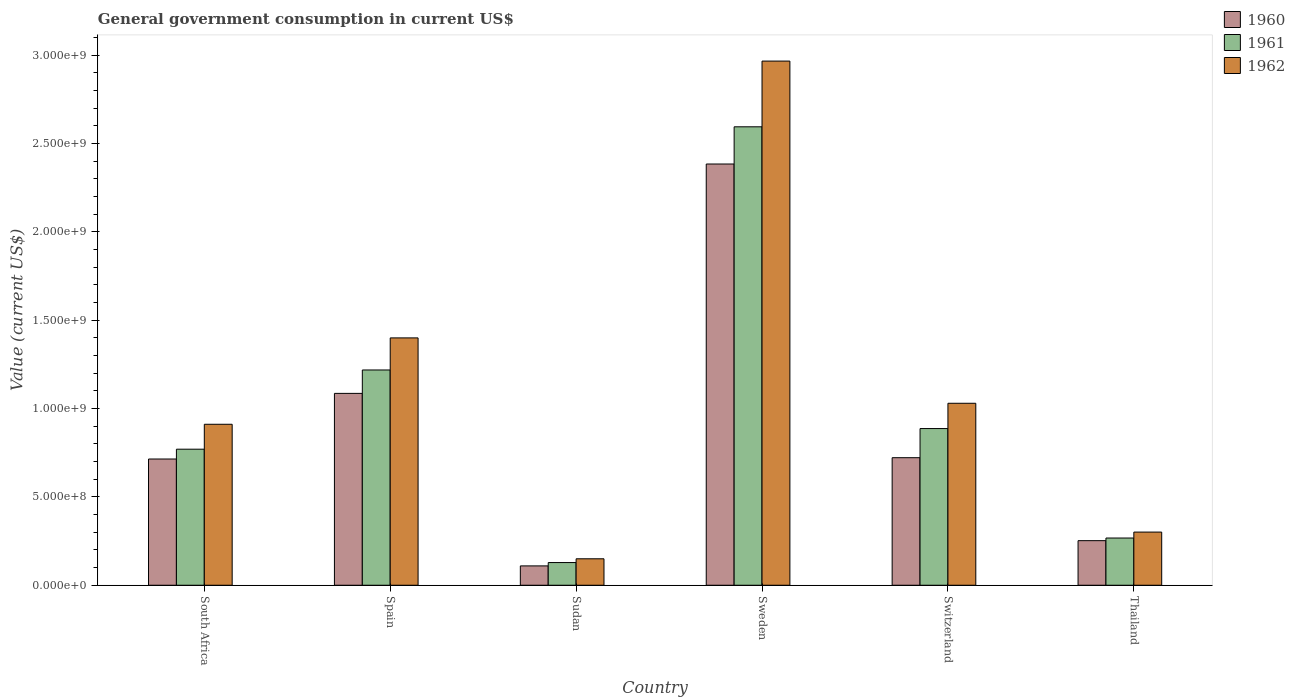How many groups of bars are there?
Your answer should be very brief. 6. Are the number of bars per tick equal to the number of legend labels?
Keep it short and to the point. Yes. Are the number of bars on each tick of the X-axis equal?
Offer a very short reply. Yes. How many bars are there on the 3rd tick from the left?
Ensure brevity in your answer.  3. How many bars are there on the 5th tick from the right?
Keep it short and to the point. 3. What is the label of the 4th group of bars from the left?
Ensure brevity in your answer.  Sweden. What is the government conusmption in 1962 in Sudan?
Your response must be concise. 1.50e+08. Across all countries, what is the maximum government conusmption in 1961?
Make the answer very short. 2.59e+09. Across all countries, what is the minimum government conusmption in 1962?
Your answer should be compact. 1.50e+08. In which country was the government conusmption in 1960 maximum?
Your answer should be very brief. Sweden. In which country was the government conusmption in 1960 minimum?
Your response must be concise. Sudan. What is the total government conusmption in 1962 in the graph?
Your response must be concise. 6.76e+09. What is the difference between the government conusmption in 1960 in Sudan and that in Sweden?
Ensure brevity in your answer.  -2.27e+09. What is the difference between the government conusmption in 1961 in Thailand and the government conusmption in 1960 in Switzerland?
Your response must be concise. -4.54e+08. What is the average government conusmption in 1961 per country?
Provide a short and direct response. 9.77e+08. What is the difference between the government conusmption of/in 1961 and government conusmption of/in 1960 in Thailand?
Ensure brevity in your answer.  1.50e+07. In how many countries, is the government conusmption in 1960 greater than 2700000000 US$?
Provide a succinct answer. 0. What is the ratio of the government conusmption in 1962 in South Africa to that in Spain?
Provide a succinct answer. 0.65. Is the difference between the government conusmption in 1961 in Spain and Sudan greater than the difference between the government conusmption in 1960 in Spain and Sudan?
Give a very brief answer. Yes. What is the difference between the highest and the second highest government conusmption in 1962?
Provide a short and direct response. 1.57e+09. What is the difference between the highest and the lowest government conusmption in 1960?
Provide a short and direct response. 2.27e+09. What does the 1st bar from the left in Thailand represents?
Give a very brief answer. 1960. What does the 1st bar from the right in Spain represents?
Your answer should be compact. 1962. How many bars are there?
Offer a terse response. 18. Are all the bars in the graph horizontal?
Give a very brief answer. No. What is the difference between two consecutive major ticks on the Y-axis?
Provide a short and direct response. 5.00e+08. Are the values on the major ticks of Y-axis written in scientific E-notation?
Provide a short and direct response. Yes. Does the graph contain grids?
Provide a succinct answer. No. How many legend labels are there?
Give a very brief answer. 3. How are the legend labels stacked?
Your answer should be very brief. Vertical. What is the title of the graph?
Offer a very short reply. General government consumption in current US$. Does "1990" appear as one of the legend labels in the graph?
Offer a very short reply. No. What is the label or title of the Y-axis?
Your answer should be very brief. Value (current US$). What is the Value (current US$) in 1960 in South Africa?
Your answer should be compact. 7.14e+08. What is the Value (current US$) in 1961 in South Africa?
Keep it short and to the point. 7.70e+08. What is the Value (current US$) in 1962 in South Africa?
Give a very brief answer. 9.11e+08. What is the Value (current US$) of 1960 in Spain?
Your answer should be very brief. 1.09e+09. What is the Value (current US$) in 1961 in Spain?
Offer a very short reply. 1.22e+09. What is the Value (current US$) of 1962 in Spain?
Keep it short and to the point. 1.40e+09. What is the Value (current US$) in 1960 in Sudan?
Your answer should be compact. 1.09e+08. What is the Value (current US$) of 1961 in Sudan?
Your answer should be very brief. 1.28e+08. What is the Value (current US$) of 1962 in Sudan?
Give a very brief answer. 1.50e+08. What is the Value (current US$) in 1960 in Sweden?
Make the answer very short. 2.38e+09. What is the Value (current US$) in 1961 in Sweden?
Offer a very short reply. 2.59e+09. What is the Value (current US$) in 1962 in Sweden?
Your answer should be very brief. 2.97e+09. What is the Value (current US$) of 1960 in Switzerland?
Make the answer very short. 7.22e+08. What is the Value (current US$) of 1961 in Switzerland?
Offer a terse response. 8.86e+08. What is the Value (current US$) in 1962 in Switzerland?
Ensure brevity in your answer.  1.03e+09. What is the Value (current US$) in 1960 in Thailand?
Ensure brevity in your answer.  2.52e+08. What is the Value (current US$) in 1961 in Thailand?
Your response must be concise. 2.67e+08. What is the Value (current US$) in 1962 in Thailand?
Ensure brevity in your answer.  3.01e+08. Across all countries, what is the maximum Value (current US$) of 1960?
Your answer should be compact. 2.38e+09. Across all countries, what is the maximum Value (current US$) in 1961?
Your answer should be compact. 2.59e+09. Across all countries, what is the maximum Value (current US$) in 1962?
Provide a succinct answer. 2.97e+09. Across all countries, what is the minimum Value (current US$) of 1960?
Your answer should be compact. 1.09e+08. Across all countries, what is the minimum Value (current US$) of 1961?
Give a very brief answer. 1.28e+08. Across all countries, what is the minimum Value (current US$) in 1962?
Offer a very short reply. 1.50e+08. What is the total Value (current US$) in 1960 in the graph?
Provide a short and direct response. 5.27e+09. What is the total Value (current US$) of 1961 in the graph?
Provide a succinct answer. 5.86e+09. What is the total Value (current US$) of 1962 in the graph?
Your answer should be compact. 6.76e+09. What is the difference between the Value (current US$) of 1960 in South Africa and that in Spain?
Make the answer very short. -3.71e+08. What is the difference between the Value (current US$) in 1961 in South Africa and that in Spain?
Offer a very short reply. -4.48e+08. What is the difference between the Value (current US$) in 1962 in South Africa and that in Spain?
Provide a succinct answer. -4.89e+08. What is the difference between the Value (current US$) of 1960 in South Africa and that in Sudan?
Offer a terse response. 6.05e+08. What is the difference between the Value (current US$) in 1961 in South Africa and that in Sudan?
Make the answer very short. 6.41e+08. What is the difference between the Value (current US$) in 1962 in South Africa and that in Sudan?
Ensure brevity in your answer.  7.61e+08. What is the difference between the Value (current US$) in 1960 in South Africa and that in Sweden?
Give a very brief answer. -1.67e+09. What is the difference between the Value (current US$) of 1961 in South Africa and that in Sweden?
Offer a very short reply. -1.82e+09. What is the difference between the Value (current US$) in 1962 in South Africa and that in Sweden?
Give a very brief answer. -2.05e+09. What is the difference between the Value (current US$) in 1960 in South Africa and that in Switzerland?
Offer a terse response. -7.44e+06. What is the difference between the Value (current US$) in 1961 in South Africa and that in Switzerland?
Your answer should be compact. -1.17e+08. What is the difference between the Value (current US$) of 1962 in South Africa and that in Switzerland?
Ensure brevity in your answer.  -1.19e+08. What is the difference between the Value (current US$) in 1960 in South Africa and that in Thailand?
Your answer should be compact. 4.62e+08. What is the difference between the Value (current US$) of 1961 in South Africa and that in Thailand?
Provide a succinct answer. 5.03e+08. What is the difference between the Value (current US$) in 1962 in South Africa and that in Thailand?
Your answer should be very brief. 6.10e+08. What is the difference between the Value (current US$) of 1960 in Spain and that in Sudan?
Ensure brevity in your answer.  9.76e+08. What is the difference between the Value (current US$) in 1961 in Spain and that in Sudan?
Provide a succinct answer. 1.09e+09. What is the difference between the Value (current US$) in 1962 in Spain and that in Sudan?
Your answer should be very brief. 1.25e+09. What is the difference between the Value (current US$) of 1960 in Spain and that in Sweden?
Provide a short and direct response. -1.30e+09. What is the difference between the Value (current US$) in 1961 in Spain and that in Sweden?
Your answer should be compact. -1.38e+09. What is the difference between the Value (current US$) of 1962 in Spain and that in Sweden?
Offer a terse response. -1.57e+09. What is the difference between the Value (current US$) of 1960 in Spain and that in Switzerland?
Provide a succinct answer. 3.64e+08. What is the difference between the Value (current US$) of 1961 in Spain and that in Switzerland?
Offer a very short reply. 3.31e+08. What is the difference between the Value (current US$) of 1962 in Spain and that in Switzerland?
Provide a succinct answer. 3.70e+08. What is the difference between the Value (current US$) in 1960 in Spain and that in Thailand?
Provide a short and direct response. 8.33e+08. What is the difference between the Value (current US$) in 1961 in Spain and that in Thailand?
Provide a short and direct response. 9.51e+08. What is the difference between the Value (current US$) of 1962 in Spain and that in Thailand?
Give a very brief answer. 1.10e+09. What is the difference between the Value (current US$) of 1960 in Sudan and that in Sweden?
Ensure brevity in your answer.  -2.27e+09. What is the difference between the Value (current US$) in 1961 in Sudan and that in Sweden?
Your answer should be compact. -2.47e+09. What is the difference between the Value (current US$) of 1962 in Sudan and that in Sweden?
Provide a short and direct response. -2.82e+09. What is the difference between the Value (current US$) in 1960 in Sudan and that in Switzerland?
Provide a succinct answer. -6.12e+08. What is the difference between the Value (current US$) of 1961 in Sudan and that in Switzerland?
Provide a succinct answer. -7.58e+08. What is the difference between the Value (current US$) of 1962 in Sudan and that in Switzerland?
Ensure brevity in your answer.  -8.80e+08. What is the difference between the Value (current US$) of 1960 in Sudan and that in Thailand?
Your response must be concise. -1.43e+08. What is the difference between the Value (current US$) of 1961 in Sudan and that in Thailand?
Offer a very short reply. -1.39e+08. What is the difference between the Value (current US$) in 1962 in Sudan and that in Thailand?
Make the answer very short. -1.51e+08. What is the difference between the Value (current US$) of 1960 in Sweden and that in Switzerland?
Make the answer very short. 1.66e+09. What is the difference between the Value (current US$) of 1961 in Sweden and that in Switzerland?
Offer a very short reply. 1.71e+09. What is the difference between the Value (current US$) in 1962 in Sweden and that in Switzerland?
Your answer should be compact. 1.94e+09. What is the difference between the Value (current US$) in 1960 in Sweden and that in Thailand?
Offer a terse response. 2.13e+09. What is the difference between the Value (current US$) in 1961 in Sweden and that in Thailand?
Provide a short and direct response. 2.33e+09. What is the difference between the Value (current US$) in 1962 in Sweden and that in Thailand?
Provide a short and direct response. 2.66e+09. What is the difference between the Value (current US$) in 1960 in Switzerland and that in Thailand?
Your answer should be very brief. 4.69e+08. What is the difference between the Value (current US$) in 1961 in Switzerland and that in Thailand?
Your answer should be compact. 6.19e+08. What is the difference between the Value (current US$) in 1962 in Switzerland and that in Thailand?
Make the answer very short. 7.29e+08. What is the difference between the Value (current US$) of 1960 in South Africa and the Value (current US$) of 1961 in Spain?
Ensure brevity in your answer.  -5.04e+08. What is the difference between the Value (current US$) in 1960 in South Africa and the Value (current US$) in 1962 in Spain?
Provide a short and direct response. -6.85e+08. What is the difference between the Value (current US$) in 1961 in South Africa and the Value (current US$) in 1962 in Spain?
Your answer should be very brief. -6.30e+08. What is the difference between the Value (current US$) in 1960 in South Africa and the Value (current US$) in 1961 in Sudan?
Offer a very short reply. 5.86e+08. What is the difference between the Value (current US$) of 1960 in South Africa and the Value (current US$) of 1962 in Sudan?
Provide a short and direct response. 5.65e+08. What is the difference between the Value (current US$) in 1961 in South Africa and the Value (current US$) in 1962 in Sudan?
Give a very brief answer. 6.20e+08. What is the difference between the Value (current US$) in 1960 in South Africa and the Value (current US$) in 1961 in Sweden?
Keep it short and to the point. -1.88e+09. What is the difference between the Value (current US$) in 1960 in South Africa and the Value (current US$) in 1962 in Sweden?
Offer a very short reply. -2.25e+09. What is the difference between the Value (current US$) in 1961 in South Africa and the Value (current US$) in 1962 in Sweden?
Offer a terse response. -2.20e+09. What is the difference between the Value (current US$) in 1960 in South Africa and the Value (current US$) in 1961 in Switzerland?
Make the answer very short. -1.72e+08. What is the difference between the Value (current US$) in 1960 in South Africa and the Value (current US$) in 1962 in Switzerland?
Your answer should be compact. -3.15e+08. What is the difference between the Value (current US$) of 1961 in South Africa and the Value (current US$) of 1962 in Switzerland?
Provide a succinct answer. -2.60e+08. What is the difference between the Value (current US$) in 1960 in South Africa and the Value (current US$) in 1961 in Thailand?
Ensure brevity in your answer.  4.47e+08. What is the difference between the Value (current US$) in 1960 in South Africa and the Value (current US$) in 1962 in Thailand?
Ensure brevity in your answer.  4.13e+08. What is the difference between the Value (current US$) of 1961 in South Africa and the Value (current US$) of 1962 in Thailand?
Give a very brief answer. 4.69e+08. What is the difference between the Value (current US$) in 1960 in Spain and the Value (current US$) in 1961 in Sudan?
Ensure brevity in your answer.  9.57e+08. What is the difference between the Value (current US$) of 1960 in Spain and the Value (current US$) of 1962 in Sudan?
Your answer should be compact. 9.36e+08. What is the difference between the Value (current US$) of 1961 in Spain and the Value (current US$) of 1962 in Sudan?
Ensure brevity in your answer.  1.07e+09. What is the difference between the Value (current US$) in 1960 in Spain and the Value (current US$) in 1961 in Sweden?
Your answer should be very brief. -1.51e+09. What is the difference between the Value (current US$) of 1960 in Spain and the Value (current US$) of 1962 in Sweden?
Provide a succinct answer. -1.88e+09. What is the difference between the Value (current US$) in 1961 in Spain and the Value (current US$) in 1962 in Sweden?
Keep it short and to the point. -1.75e+09. What is the difference between the Value (current US$) of 1960 in Spain and the Value (current US$) of 1961 in Switzerland?
Your response must be concise. 1.99e+08. What is the difference between the Value (current US$) of 1960 in Spain and the Value (current US$) of 1962 in Switzerland?
Offer a terse response. 5.60e+07. What is the difference between the Value (current US$) of 1961 in Spain and the Value (current US$) of 1962 in Switzerland?
Keep it short and to the point. 1.88e+08. What is the difference between the Value (current US$) of 1960 in Spain and the Value (current US$) of 1961 in Thailand?
Keep it short and to the point. 8.18e+08. What is the difference between the Value (current US$) of 1960 in Spain and the Value (current US$) of 1962 in Thailand?
Your answer should be compact. 7.85e+08. What is the difference between the Value (current US$) of 1961 in Spain and the Value (current US$) of 1962 in Thailand?
Ensure brevity in your answer.  9.17e+08. What is the difference between the Value (current US$) in 1960 in Sudan and the Value (current US$) in 1961 in Sweden?
Ensure brevity in your answer.  -2.48e+09. What is the difference between the Value (current US$) in 1960 in Sudan and the Value (current US$) in 1962 in Sweden?
Provide a short and direct response. -2.86e+09. What is the difference between the Value (current US$) of 1961 in Sudan and the Value (current US$) of 1962 in Sweden?
Your answer should be compact. -2.84e+09. What is the difference between the Value (current US$) in 1960 in Sudan and the Value (current US$) in 1961 in Switzerland?
Keep it short and to the point. -7.77e+08. What is the difference between the Value (current US$) in 1960 in Sudan and the Value (current US$) in 1962 in Switzerland?
Offer a very short reply. -9.20e+08. What is the difference between the Value (current US$) of 1961 in Sudan and the Value (current US$) of 1962 in Switzerland?
Offer a terse response. -9.01e+08. What is the difference between the Value (current US$) of 1960 in Sudan and the Value (current US$) of 1961 in Thailand?
Provide a succinct answer. -1.58e+08. What is the difference between the Value (current US$) in 1960 in Sudan and the Value (current US$) in 1962 in Thailand?
Keep it short and to the point. -1.91e+08. What is the difference between the Value (current US$) in 1961 in Sudan and the Value (current US$) in 1962 in Thailand?
Provide a succinct answer. -1.72e+08. What is the difference between the Value (current US$) in 1960 in Sweden and the Value (current US$) in 1961 in Switzerland?
Keep it short and to the point. 1.50e+09. What is the difference between the Value (current US$) of 1960 in Sweden and the Value (current US$) of 1962 in Switzerland?
Offer a terse response. 1.35e+09. What is the difference between the Value (current US$) of 1961 in Sweden and the Value (current US$) of 1962 in Switzerland?
Provide a short and direct response. 1.56e+09. What is the difference between the Value (current US$) of 1960 in Sweden and the Value (current US$) of 1961 in Thailand?
Your answer should be very brief. 2.12e+09. What is the difference between the Value (current US$) of 1960 in Sweden and the Value (current US$) of 1962 in Thailand?
Your response must be concise. 2.08e+09. What is the difference between the Value (current US$) in 1961 in Sweden and the Value (current US$) in 1962 in Thailand?
Offer a terse response. 2.29e+09. What is the difference between the Value (current US$) in 1960 in Switzerland and the Value (current US$) in 1961 in Thailand?
Offer a very short reply. 4.54e+08. What is the difference between the Value (current US$) of 1960 in Switzerland and the Value (current US$) of 1962 in Thailand?
Make the answer very short. 4.21e+08. What is the difference between the Value (current US$) of 1961 in Switzerland and the Value (current US$) of 1962 in Thailand?
Keep it short and to the point. 5.86e+08. What is the average Value (current US$) of 1960 per country?
Offer a terse response. 8.78e+08. What is the average Value (current US$) of 1961 per country?
Ensure brevity in your answer.  9.77e+08. What is the average Value (current US$) of 1962 per country?
Provide a short and direct response. 1.13e+09. What is the difference between the Value (current US$) of 1960 and Value (current US$) of 1961 in South Africa?
Your answer should be compact. -5.55e+07. What is the difference between the Value (current US$) in 1960 and Value (current US$) in 1962 in South Africa?
Offer a very short reply. -1.97e+08. What is the difference between the Value (current US$) in 1961 and Value (current US$) in 1962 in South Africa?
Your answer should be very brief. -1.41e+08. What is the difference between the Value (current US$) of 1960 and Value (current US$) of 1961 in Spain?
Ensure brevity in your answer.  -1.32e+08. What is the difference between the Value (current US$) of 1960 and Value (current US$) of 1962 in Spain?
Your answer should be compact. -3.14e+08. What is the difference between the Value (current US$) in 1961 and Value (current US$) in 1962 in Spain?
Offer a terse response. -1.82e+08. What is the difference between the Value (current US$) of 1960 and Value (current US$) of 1961 in Sudan?
Your answer should be very brief. -1.90e+07. What is the difference between the Value (current US$) in 1960 and Value (current US$) in 1962 in Sudan?
Ensure brevity in your answer.  -4.02e+07. What is the difference between the Value (current US$) in 1961 and Value (current US$) in 1962 in Sudan?
Offer a terse response. -2.13e+07. What is the difference between the Value (current US$) in 1960 and Value (current US$) in 1961 in Sweden?
Offer a very short reply. -2.10e+08. What is the difference between the Value (current US$) in 1960 and Value (current US$) in 1962 in Sweden?
Make the answer very short. -5.82e+08. What is the difference between the Value (current US$) of 1961 and Value (current US$) of 1962 in Sweden?
Your answer should be compact. -3.72e+08. What is the difference between the Value (current US$) in 1960 and Value (current US$) in 1961 in Switzerland?
Provide a short and direct response. -1.65e+08. What is the difference between the Value (current US$) in 1960 and Value (current US$) in 1962 in Switzerland?
Provide a succinct answer. -3.08e+08. What is the difference between the Value (current US$) of 1961 and Value (current US$) of 1962 in Switzerland?
Ensure brevity in your answer.  -1.43e+08. What is the difference between the Value (current US$) in 1960 and Value (current US$) in 1961 in Thailand?
Make the answer very short. -1.50e+07. What is the difference between the Value (current US$) of 1960 and Value (current US$) of 1962 in Thailand?
Provide a short and direct response. -4.86e+07. What is the difference between the Value (current US$) in 1961 and Value (current US$) in 1962 in Thailand?
Your answer should be compact. -3.36e+07. What is the ratio of the Value (current US$) of 1960 in South Africa to that in Spain?
Give a very brief answer. 0.66. What is the ratio of the Value (current US$) of 1961 in South Africa to that in Spain?
Provide a succinct answer. 0.63. What is the ratio of the Value (current US$) in 1962 in South Africa to that in Spain?
Give a very brief answer. 0.65. What is the ratio of the Value (current US$) in 1960 in South Africa to that in Sudan?
Provide a succinct answer. 6.53. What is the ratio of the Value (current US$) in 1961 in South Africa to that in Sudan?
Ensure brevity in your answer.  6. What is the ratio of the Value (current US$) in 1962 in South Africa to that in Sudan?
Provide a succinct answer. 6.09. What is the ratio of the Value (current US$) in 1960 in South Africa to that in Sweden?
Ensure brevity in your answer.  0.3. What is the ratio of the Value (current US$) in 1961 in South Africa to that in Sweden?
Offer a very short reply. 0.3. What is the ratio of the Value (current US$) in 1962 in South Africa to that in Sweden?
Offer a very short reply. 0.31. What is the ratio of the Value (current US$) in 1960 in South Africa to that in Switzerland?
Keep it short and to the point. 0.99. What is the ratio of the Value (current US$) of 1961 in South Africa to that in Switzerland?
Ensure brevity in your answer.  0.87. What is the ratio of the Value (current US$) in 1962 in South Africa to that in Switzerland?
Make the answer very short. 0.88. What is the ratio of the Value (current US$) in 1960 in South Africa to that in Thailand?
Provide a short and direct response. 2.83. What is the ratio of the Value (current US$) of 1961 in South Africa to that in Thailand?
Your answer should be very brief. 2.88. What is the ratio of the Value (current US$) in 1962 in South Africa to that in Thailand?
Your answer should be compact. 3.03. What is the ratio of the Value (current US$) in 1960 in Spain to that in Sudan?
Your answer should be very brief. 9.92. What is the ratio of the Value (current US$) in 1961 in Spain to that in Sudan?
Provide a short and direct response. 9.49. What is the ratio of the Value (current US$) in 1962 in Spain to that in Sudan?
Offer a very short reply. 9.35. What is the ratio of the Value (current US$) of 1960 in Spain to that in Sweden?
Your answer should be very brief. 0.46. What is the ratio of the Value (current US$) in 1961 in Spain to that in Sweden?
Give a very brief answer. 0.47. What is the ratio of the Value (current US$) in 1962 in Spain to that in Sweden?
Keep it short and to the point. 0.47. What is the ratio of the Value (current US$) of 1960 in Spain to that in Switzerland?
Offer a very short reply. 1.5. What is the ratio of the Value (current US$) of 1961 in Spain to that in Switzerland?
Keep it short and to the point. 1.37. What is the ratio of the Value (current US$) of 1962 in Spain to that in Switzerland?
Your answer should be very brief. 1.36. What is the ratio of the Value (current US$) of 1960 in Spain to that in Thailand?
Provide a short and direct response. 4.3. What is the ratio of the Value (current US$) of 1961 in Spain to that in Thailand?
Provide a succinct answer. 4.56. What is the ratio of the Value (current US$) in 1962 in Spain to that in Thailand?
Provide a short and direct response. 4.65. What is the ratio of the Value (current US$) of 1960 in Sudan to that in Sweden?
Ensure brevity in your answer.  0.05. What is the ratio of the Value (current US$) of 1961 in Sudan to that in Sweden?
Offer a terse response. 0.05. What is the ratio of the Value (current US$) of 1962 in Sudan to that in Sweden?
Provide a short and direct response. 0.05. What is the ratio of the Value (current US$) in 1960 in Sudan to that in Switzerland?
Offer a very short reply. 0.15. What is the ratio of the Value (current US$) of 1961 in Sudan to that in Switzerland?
Give a very brief answer. 0.14. What is the ratio of the Value (current US$) in 1962 in Sudan to that in Switzerland?
Offer a terse response. 0.15. What is the ratio of the Value (current US$) of 1960 in Sudan to that in Thailand?
Ensure brevity in your answer.  0.43. What is the ratio of the Value (current US$) of 1961 in Sudan to that in Thailand?
Make the answer very short. 0.48. What is the ratio of the Value (current US$) in 1962 in Sudan to that in Thailand?
Keep it short and to the point. 0.5. What is the ratio of the Value (current US$) in 1960 in Sweden to that in Switzerland?
Your answer should be compact. 3.3. What is the ratio of the Value (current US$) in 1961 in Sweden to that in Switzerland?
Your answer should be compact. 2.93. What is the ratio of the Value (current US$) in 1962 in Sweden to that in Switzerland?
Keep it short and to the point. 2.88. What is the ratio of the Value (current US$) in 1960 in Sweden to that in Thailand?
Your response must be concise. 9.45. What is the ratio of the Value (current US$) of 1961 in Sweden to that in Thailand?
Give a very brief answer. 9.71. What is the ratio of the Value (current US$) of 1962 in Sweden to that in Thailand?
Offer a terse response. 9.86. What is the ratio of the Value (current US$) of 1960 in Switzerland to that in Thailand?
Offer a very short reply. 2.86. What is the ratio of the Value (current US$) of 1961 in Switzerland to that in Thailand?
Make the answer very short. 3.32. What is the ratio of the Value (current US$) of 1962 in Switzerland to that in Thailand?
Give a very brief answer. 3.42. What is the difference between the highest and the second highest Value (current US$) of 1960?
Give a very brief answer. 1.30e+09. What is the difference between the highest and the second highest Value (current US$) of 1961?
Give a very brief answer. 1.38e+09. What is the difference between the highest and the second highest Value (current US$) of 1962?
Ensure brevity in your answer.  1.57e+09. What is the difference between the highest and the lowest Value (current US$) in 1960?
Ensure brevity in your answer.  2.27e+09. What is the difference between the highest and the lowest Value (current US$) of 1961?
Provide a short and direct response. 2.47e+09. What is the difference between the highest and the lowest Value (current US$) in 1962?
Provide a short and direct response. 2.82e+09. 